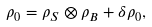Convert formula to latex. <formula><loc_0><loc_0><loc_500><loc_500>\rho _ { 0 } = \rho _ { S } \otimes \rho _ { B } + \delta \rho _ { 0 } ,</formula> 